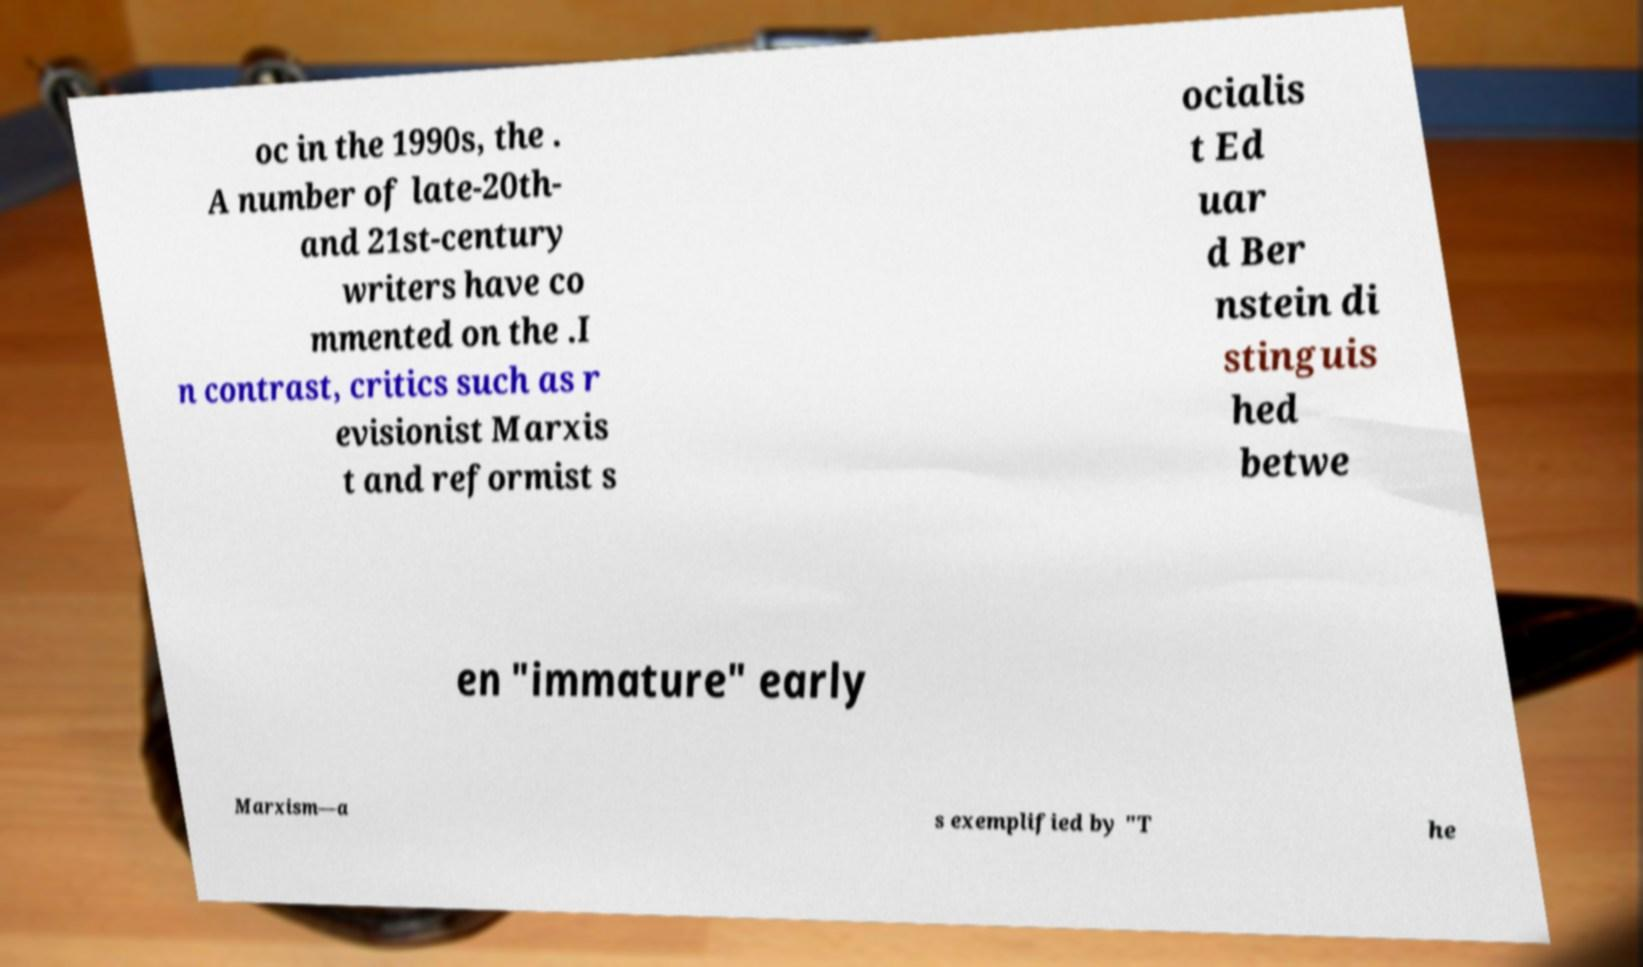Can you read and provide the text displayed in the image?This photo seems to have some interesting text. Can you extract and type it out for me? oc in the 1990s, the . A number of late-20th- and 21st-century writers have co mmented on the .I n contrast, critics such as r evisionist Marxis t and reformist s ocialis t Ed uar d Ber nstein di stinguis hed betwe en "immature" early Marxism—a s exemplified by "T he 